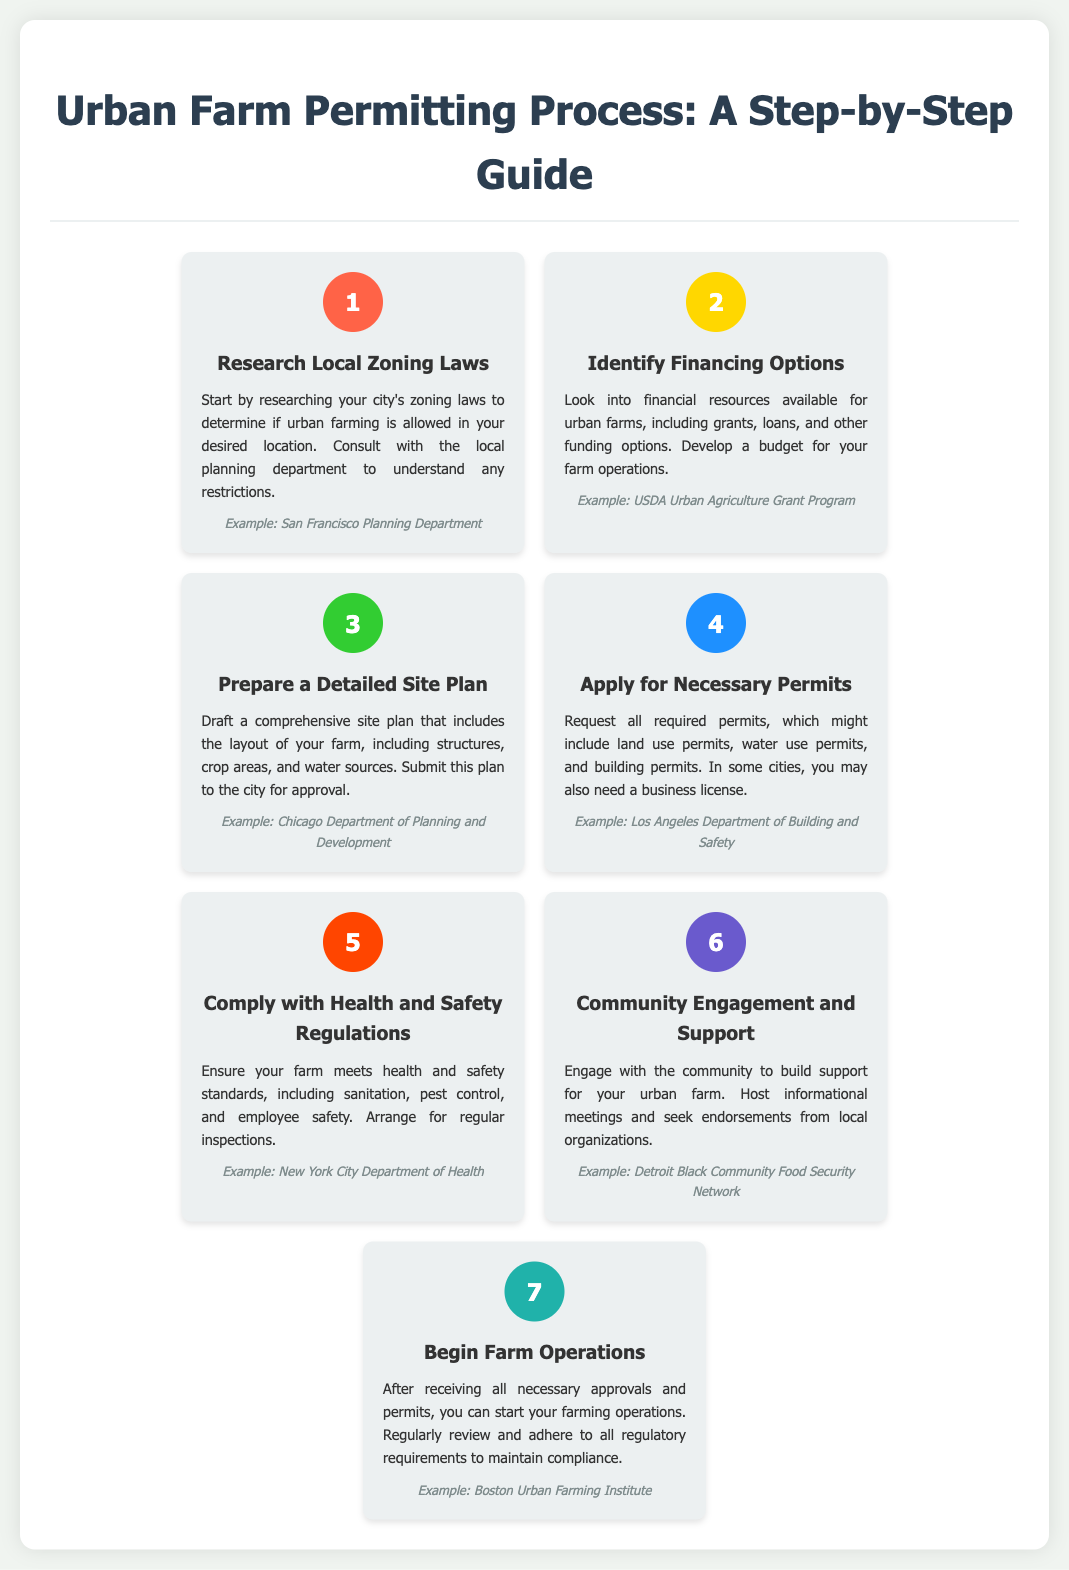what is the first step in the urban farm permitting process? The first step is to research local zoning laws to determine if urban farming is allowed in your desired location.
Answer: Research Local Zoning Laws what is the color associated with the second step? The second step is represented by a yellow color, specifically the hex color #FFD700.
Answer: #FFD700 which department example is associated with the third step? The example given for the third step, which involves preparing a detailed site plan, is the Chicago Department of Planning and Development.
Answer: Chicago Department of Planning and Development how many total steps are there in the urban farm permitting process? There are a total of seven steps highlighted in the document.
Answer: 7 what is the final step in the process? The final step involves beginning farm operations after receiving all necessary approvals and permits.
Answer: Begin Farm Operations which step focuses on community involvement? The step that emphasizes engaging with the community for support is the sixth step in the process.
Answer: Community Engagement and Support what type of permits may be requested in the fourth step? In the fourth step, one may request land use permits, water use permits, and building permits.
Answer: land use permits, water use permits, building permits what is the main purpose of the second step? The main purpose of the second step is to identify financing options for the urban farm.
Answer: Identify Financing Options 